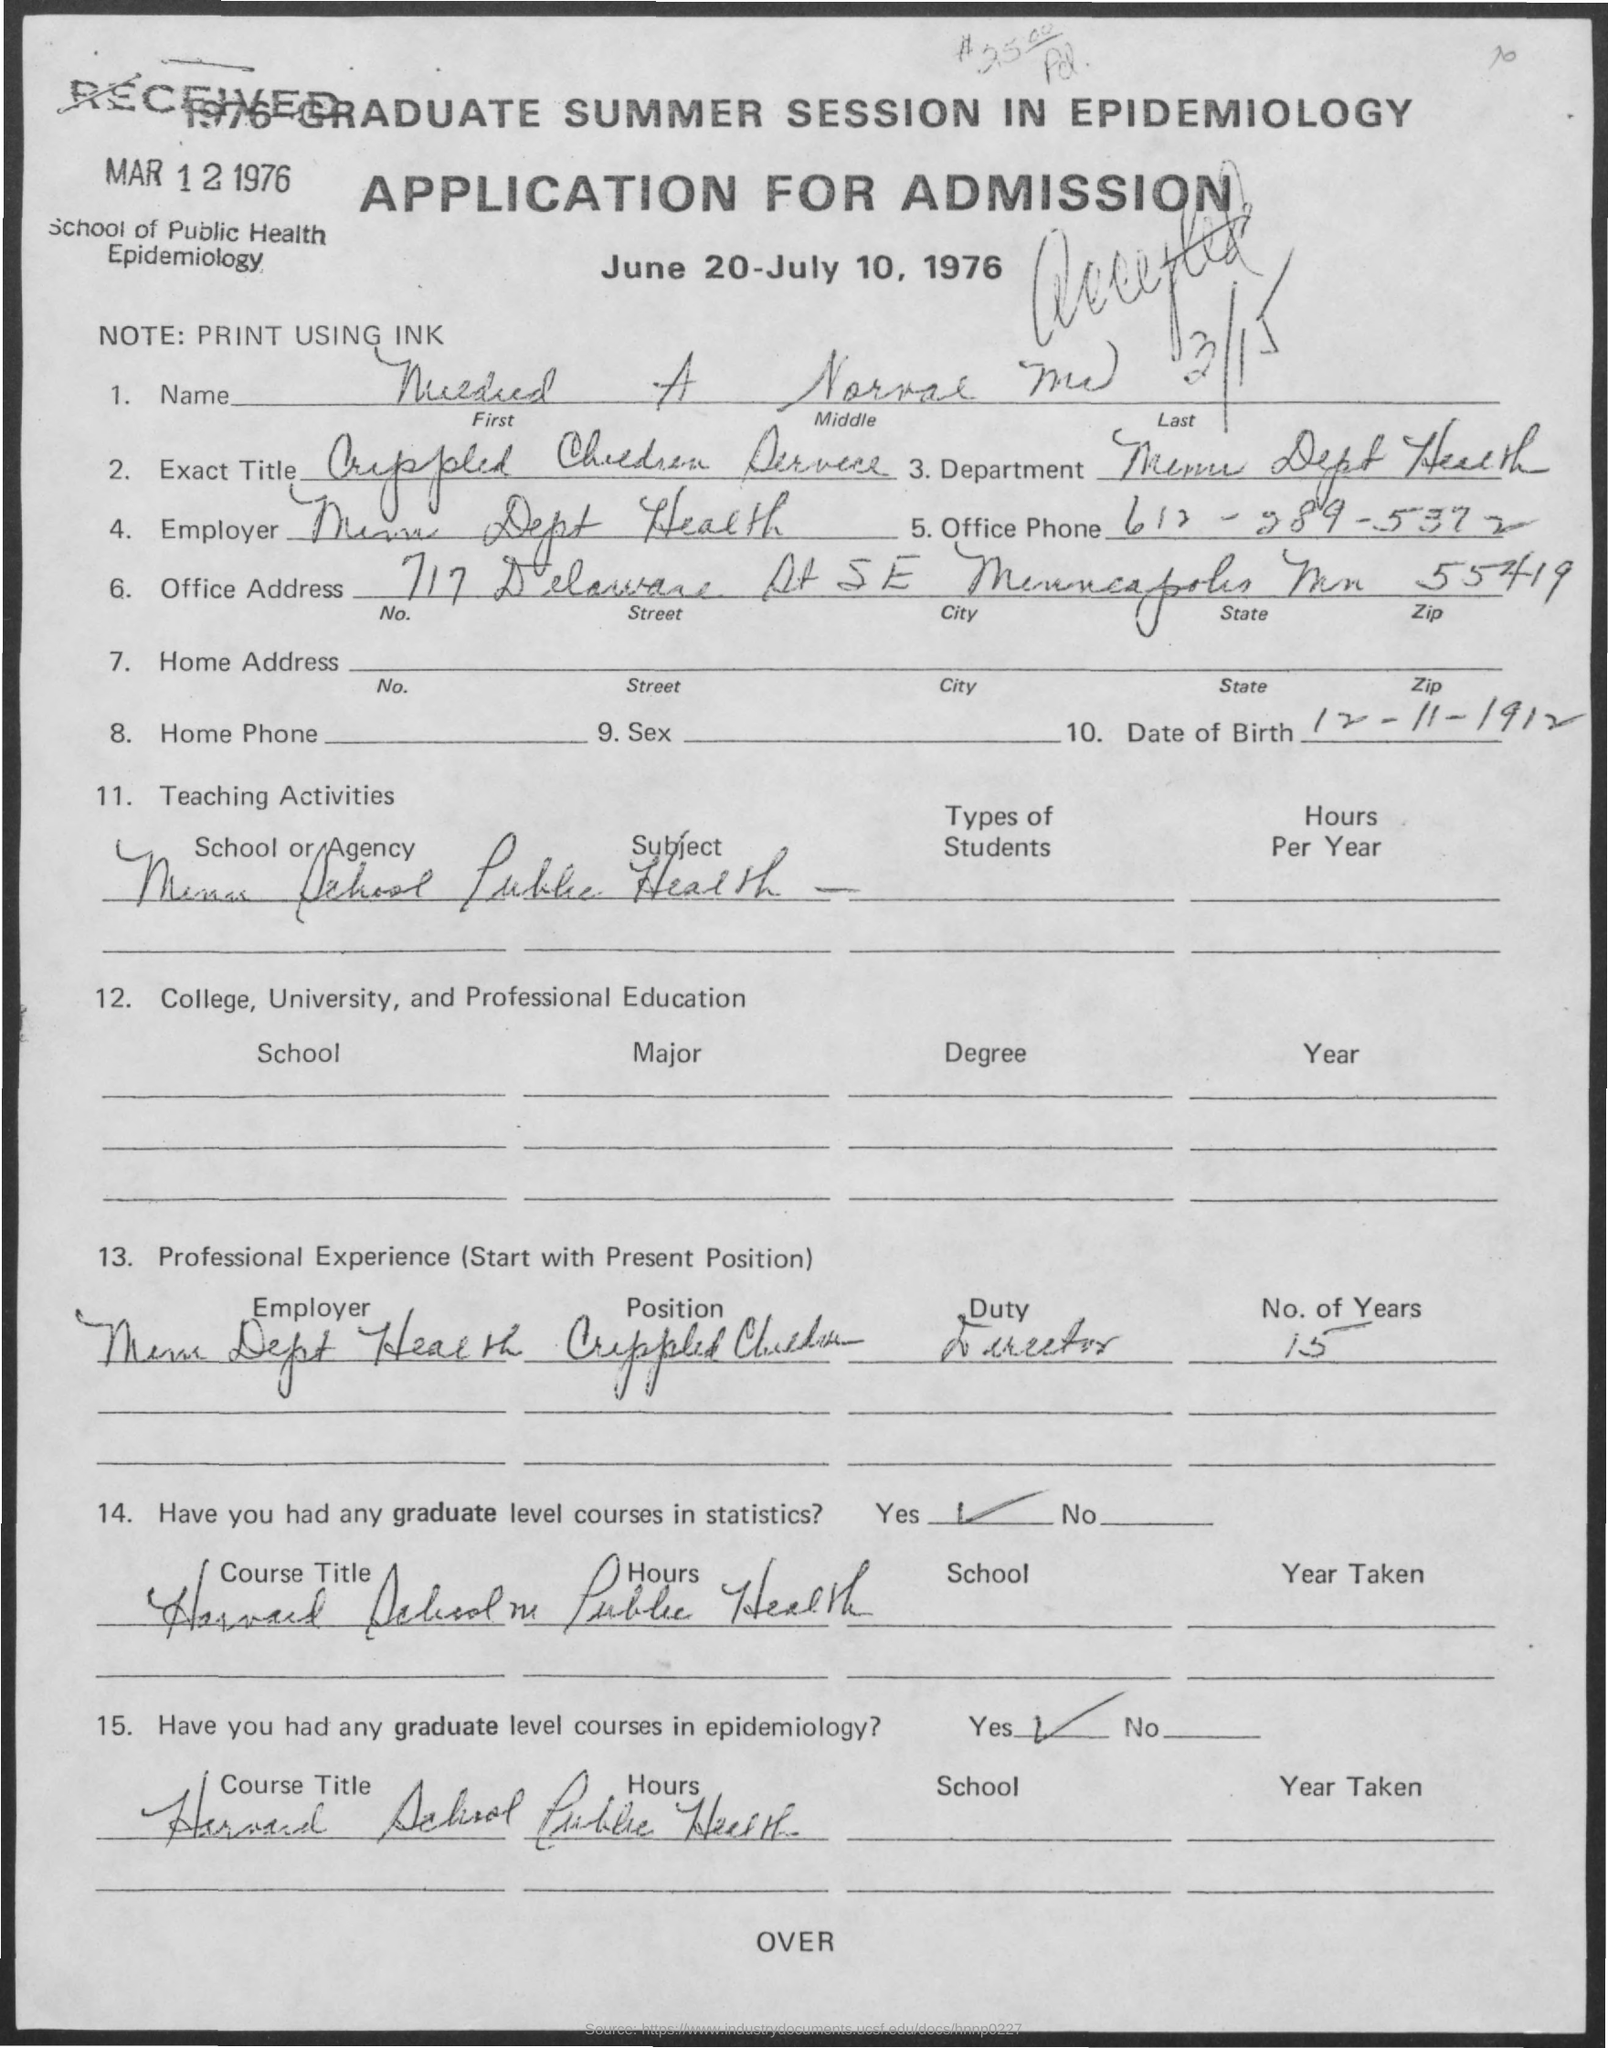What is the note mentioned in the given application ?
Provide a short and direct response. Print using ink. What is the date of birth mentioned in the given application ?
Your answer should be very brief. 12-11-1912. Does he have any graduate level courses in statistics ?
Offer a terse response. Yes. Does he have any graduate level courses in epidemiology ?
Keep it short and to the point. Yes. What is the name of the school as mentioned in the given application ?
Make the answer very short. School of public health epidemiology. 